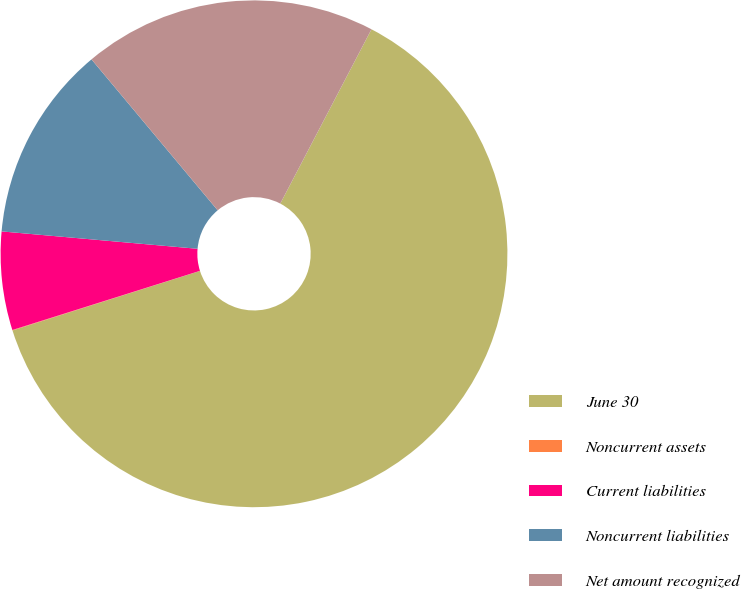<chart> <loc_0><loc_0><loc_500><loc_500><pie_chart><fcel>June 30<fcel>Noncurrent assets<fcel>Current liabilities<fcel>Noncurrent liabilities<fcel>Net amount recognized<nl><fcel>62.43%<fcel>0.03%<fcel>6.27%<fcel>12.51%<fcel>18.75%<nl></chart> 